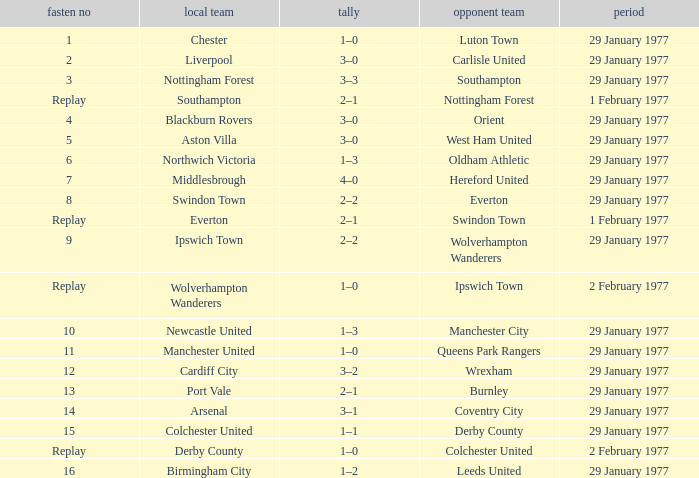What is the tie number when the home team is Port Vale? 13.0. 